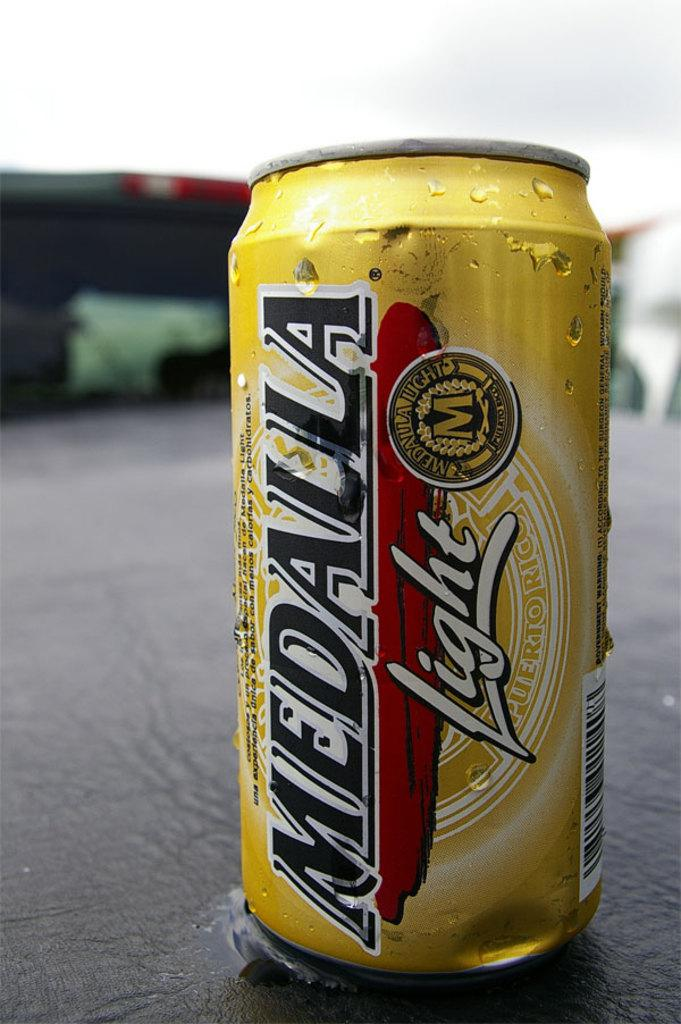<image>
Describe the image concisely. A can has the Medalla light logo on the side. 